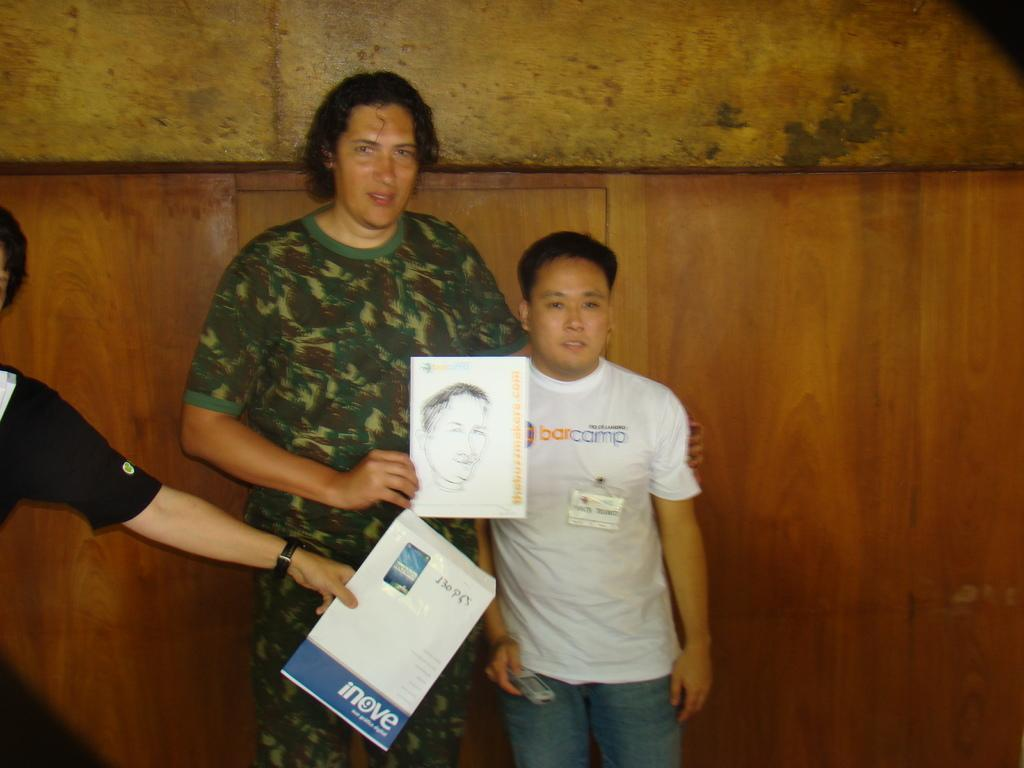How many people are present in the image? There are three people in the image. What are the people holding in the image? The people are holding books. What can be seen in the background of the image? There is a wall visible in the background of the image. What type of laughter can be heard coming from the people in the image? There is no indication of laughter in the image, as the people are holding books and not making any audible sounds. 